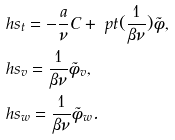Convert formula to latex. <formula><loc_0><loc_0><loc_500><loc_500>& \ h s _ { t } = - \frac { a } { \nu } C + \ p t ( \frac { 1 } { \beta \nu } ) \tilde { \phi } , \\ & \ h s _ { v } = \frac { 1 } { \beta \nu } \tilde { \phi } _ { v } , \\ & \ h s _ { w } = \frac { 1 } { \beta \nu } \tilde { \phi } _ { w } .</formula> 